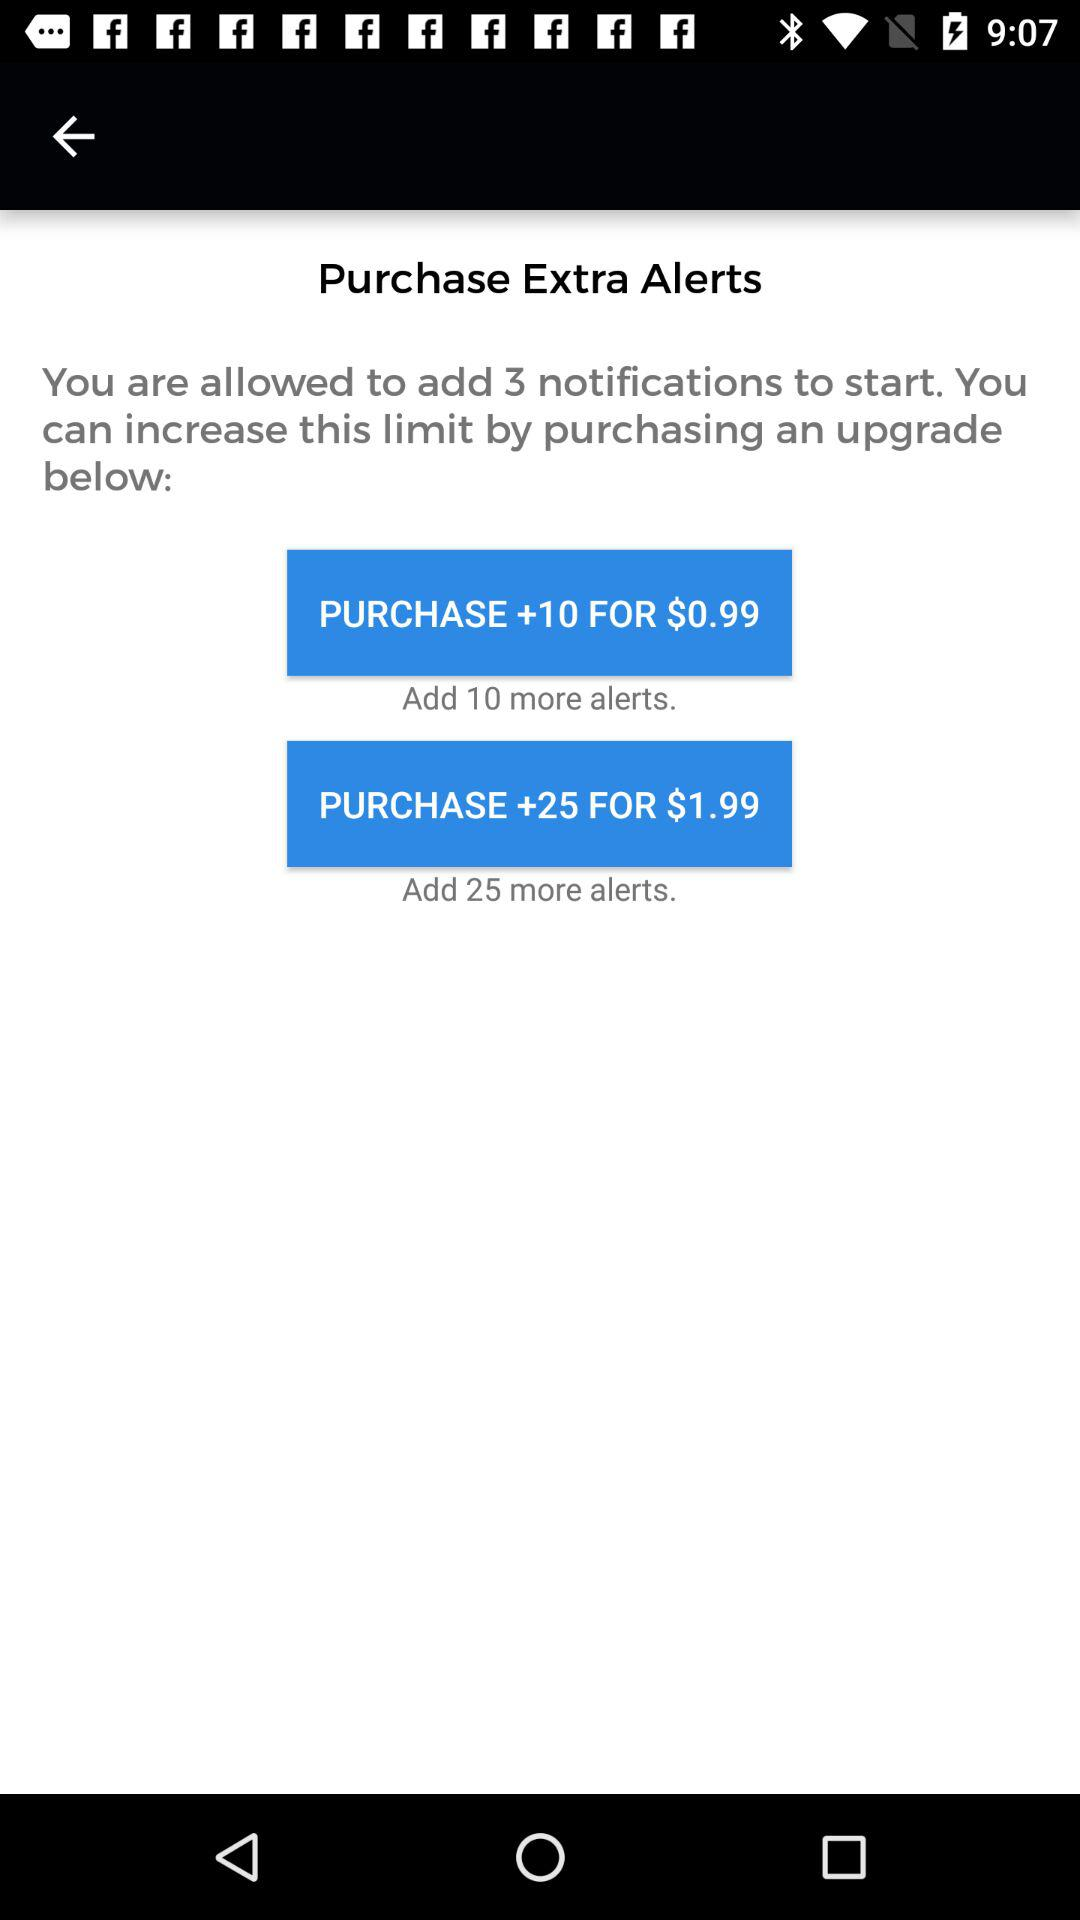What is the price to purchase +25 alerts? The price to purchase +25 alerts is $1.99. 